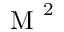<formula> <loc_0><loc_0><loc_500><loc_500>M ^ { 2 }</formula> 